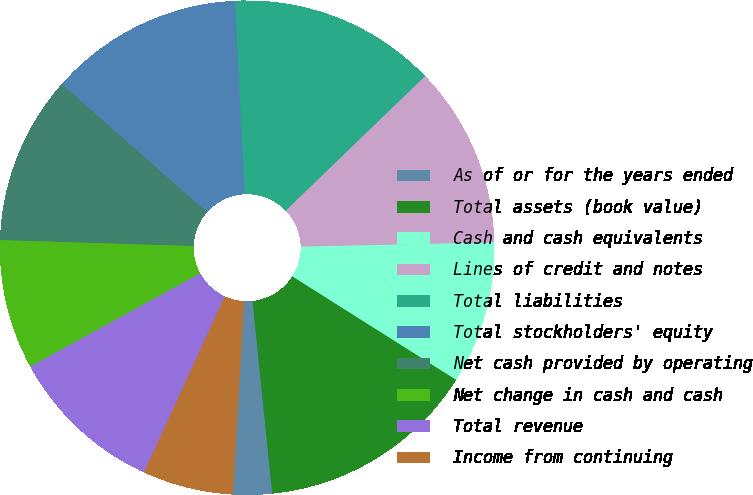<chart> <loc_0><loc_0><loc_500><loc_500><pie_chart><fcel>As of or for the years ended<fcel>Total assets (book value)<fcel>Cash and cash equivalents<fcel>Lines of credit and notes<fcel>Total liabilities<fcel>Total stockholders' equity<fcel>Net cash provided by operating<fcel>Net change in cash and cash<fcel>Total revenue<fcel>Income from continuing<nl><fcel>2.54%<fcel>14.41%<fcel>9.32%<fcel>11.86%<fcel>13.56%<fcel>12.71%<fcel>11.02%<fcel>8.47%<fcel>10.17%<fcel>5.93%<nl></chart> 